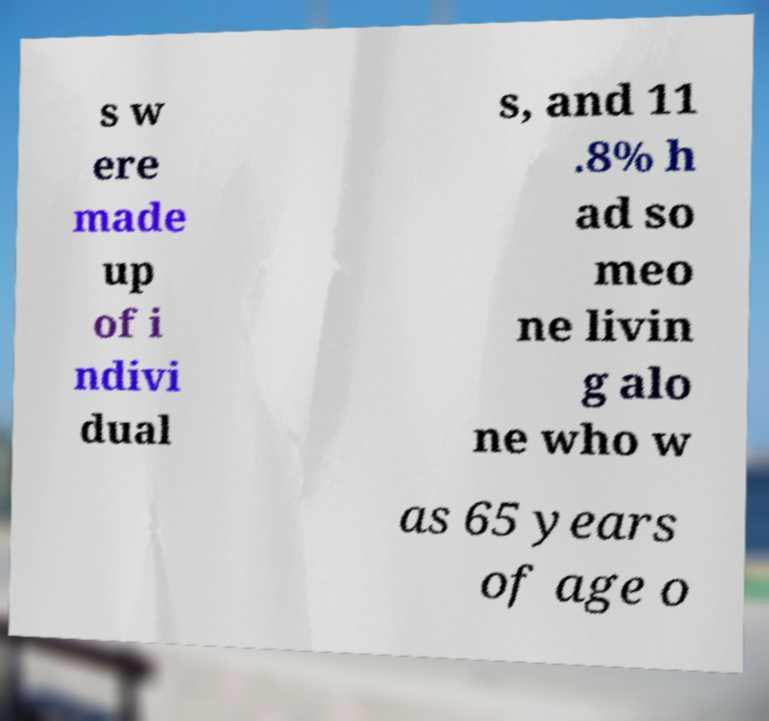Could you assist in decoding the text presented in this image and type it out clearly? s w ere made up of i ndivi dual s, and 11 .8% h ad so meo ne livin g alo ne who w as 65 years of age o 